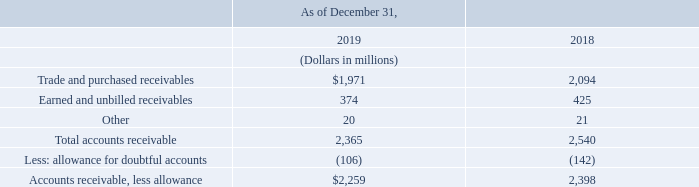(8) Accounts Receivable
The following table presents details of our accounts receivable balances:
We are exposed to concentrations of credit risk from residential and business customers. We generally do not require collateral to secure our receivable balances. We have agreements with other communications service providers whereby we agree to bill and collect on their behalf for services rendered by those providers to our customers within our local service area. We purchase accounts receivable from other communications service providers primarily on a recourse basis and include these amounts in our accounts receivable balance. We have not experienced any significant loss associated with these purchased receivables.
How is the purchase of accounts receivable from other communications service providers done? Primarily on a recourse basis. What do the agreements with other communications service providers comprise of? Agree to bill and collect on their behalf for services rendered by those providers to our customers within our local service area. What are the types of accounts receivables highlighted in the table? Trade and purchased receivables, earned and unbilled receivables, other. How many types of accounts receivables are highlighted in the table? Trade and purchased receivables##Earned and unbilled receivables##Other
Answer: 3. What is the change in the earned and unbilled receivables?
Answer scale should be: million. 374-425
Answer: -51. What is the percentage change in the earned and unbilled receivables?
Answer scale should be: percent. (374-425)/425
Answer: -12. 